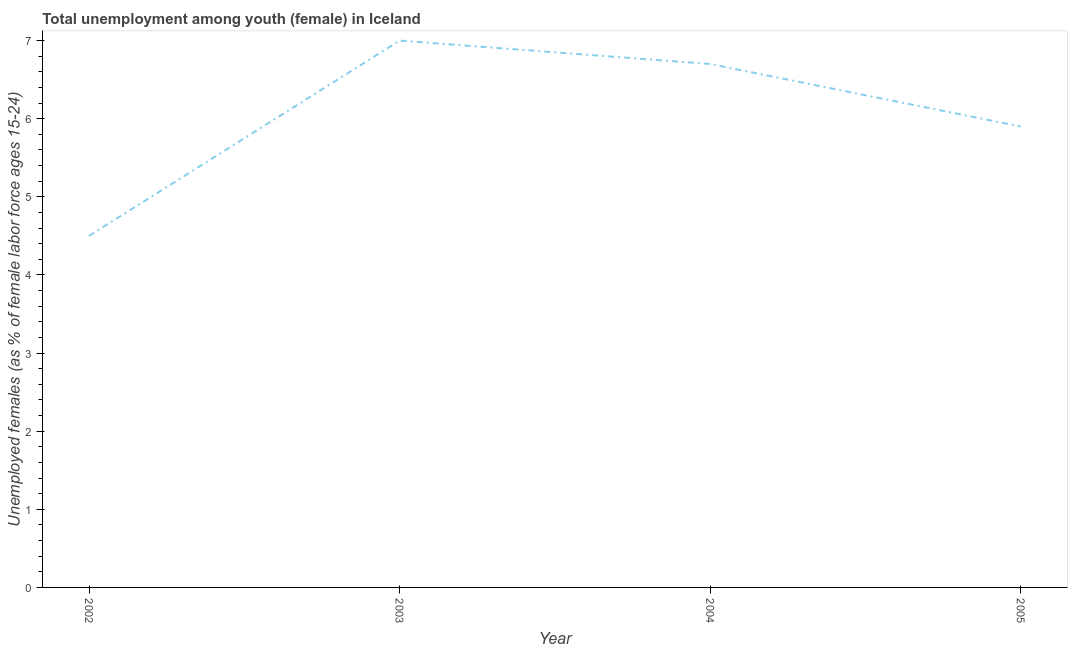Across all years, what is the minimum unemployed female youth population?
Give a very brief answer. 4.5. In which year was the unemployed female youth population minimum?
Provide a succinct answer. 2002. What is the sum of the unemployed female youth population?
Offer a very short reply. 24.1. What is the difference between the unemployed female youth population in 2003 and 2004?
Provide a short and direct response. 0.3. What is the average unemployed female youth population per year?
Your answer should be compact. 6.02. What is the median unemployed female youth population?
Provide a succinct answer. 6.3. Do a majority of the years between 2004 and 2002 (inclusive) have unemployed female youth population greater than 3.6 %?
Provide a succinct answer. No. What is the ratio of the unemployed female youth population in 2002 to that in 2004?
Ensure brevity in your answer.  0.67. Is the unemployed female youth population in 2002 less than that in 2005?
Give a very brief answer. Yes. What is the difference between the highest and the second highest unemployed female youth population?
Your response must be concise. 0.3. Is the sum of the unemployed female youth population in 2002 and 2005 greater than the maximum unemployed female youth population across all years?
Make the answer very short. Yes. What is the difference between the highest and the lowest unemployed female youth population?
Your answer should be very brief. 2.5. In how many years, is the unemployed female youth population greater than the average unemployed female youth population taken over all years?
Your answer should be very brief. 2. How many lines are there?
Give a very brief answer. 1. How many years are there in the graph?
Keep it short and to the point. 4. What is the title of the graph?
Offer a terse response. Total unemployment among youth (female) in Iceland. What is the label or title of the Y-axis?
Offer a very short reply. Unemployed females (as % of female labor force ages 15-24). What is the Unemployed females (as % of female labor force ages 15-24) of 2003?
Provide a short and direct response. 7. What is the Unemployed females (as % of female labor force ages 15-24) of 2004?
Your answer should be compact. 6.7. What is the Unemployed females (as % of female labor force ages 15-24) of 2005?
Provide a succinct answer. 5.9. What is the difference between the Unemployed females (as % of female labor force ages 15-24) in 2002 and 2003?
Make the answer very short. -2.5. What is the difference between the Unemployed females (as % of female labor force ages 15-24) in 2003 and 2005?
Ensure brevity in your answer.  1.1. What is the ratio of the Unemployed females (as % of female labor force ages 15-24) in 2002 to that in 2003?
Your response must be concise. 0.64. What is the ratio of the Unemployed females (as % of female labor force ages 15-24) in 2002 to that in 2004?
Your response must be concise. 0.67. What is the ratio of the Unemployed females (as % of female labor force ages 15-24) in 2002 to that in 2005?
Keep it short and to the point. 0.76. What is the ratio of the Unemployed females (as % of female labor force ages 15-24) in 2003 to that in 2004?
Your response must be concise. 1.04. What is the ratio of the Unemployed females (as % of female labor force ages 15-24) in 2003 to that in 2005?
Ensure brevity in your answer.  1.19. What is the ratio of the Unemployed females (as % of female labor force ages 15-24) in 2004 to that in 2005?
Your response must be concise. 1.14. 